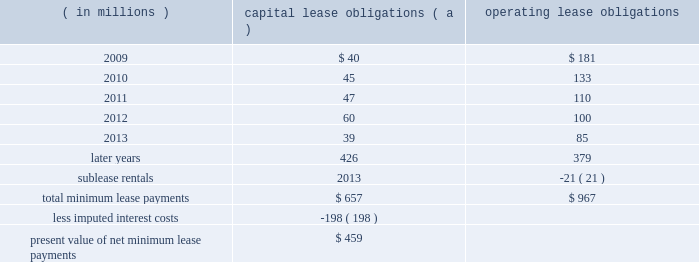Marathon oil corporation notes to consolidated financial statements preferred shares 2013 in connection with the acquisition of western discussed in note 6 , the board of directors authorized a class of voting preferred stock consisting of 6 million shares .
Upon completion of the acquisition , we issued 5 million shares of this voting preferred stock to a trustee , who holds the shares for the benefit of the holders of the exchangeable shares discussed above .
Each share of voting preferred stock is entitled to one vote on all matters submitted to the holders of marathon common stock .
Each holder of exchangeable shares may direct the trustee to vote the number of shares of voting preferred stock equal to the number of shares of marathon common stock issuable upon the exchange of the exchangeable shares held by that holder .
In no event will the aggregate number of votes entitled to be cast by the trustee with respect to the outstanding shares of voting preferred stock exceed the number of votes entitled to be cast with respect to the outstanding exchangeable shares .
Except as otherwise provided in our restated certificate of incorporation or by applicable law , the common stock and the voting preferred stock will vote together as a single class in the election of directors of marathon and on all other matters submitted to a vote of stockholders of marathon generally .
The voting preferred stock will have no other voting rights except as required by law .
Other than dividends payable solely in shares of voting preferred stock , no dividend or other distribution , will be paid or payable to the holder of the voting preferred stock .
In the event of any liquidation , dissolution or winding up of marathon , the holder of shares of the voting preferred stock will not be entitled to receive any assets of marathon available for distribution to its stockholders .
The voting preferred stock is not convertible into any other class or series of the capital stock of marathon or into cash , property or other rights , and may not be redeemed .
26 .
Leases we lease a wide variety of facilities and equipment under operating leases , including land and building space , office equipment , production facilities and transportation equipment .
Most long-term leases include renewal options and , in certain leases , purchase options .
Future minimum commitments for capital lease obligations ( including sale-leasebacks accounted for as financings ) and for operating lease obligations having initial or remaining noncancelable lease terms in excess of one year are as follows : ( in millions ) capital obligations ( a ) operating obligations .
( a ) capital lease obligations includes $ 335 million related to assets under construction as of december 31 , 2008 .
These leases are currently reported in long-term debt based on percentage of construction completed at $ 126 million .
In connection with past sales of various plants and operations , we assigned and the purchasers assumed certain leases of major equipment used in the divested plants and operations of united states steel .
In the event of a default by any of the purchasers , united states steel has assumed these obligations ; however , we remain primarily obligated for payments under these leases .
Minimum lease payments under these operating lease obligations of $ 21 million have been included above and an equal amount has been reported as sublease rentals .
Of the $ 459 million present value of net minimum capital lease payments , $ 69 million was related to obligations assumed by united states steel under the financial matters agreement. .
What is the percentage of completion for the assets under construction as of december 31 , 2008?\\n? 
Computations: (126 / 335)
Answer: 0.37612. 